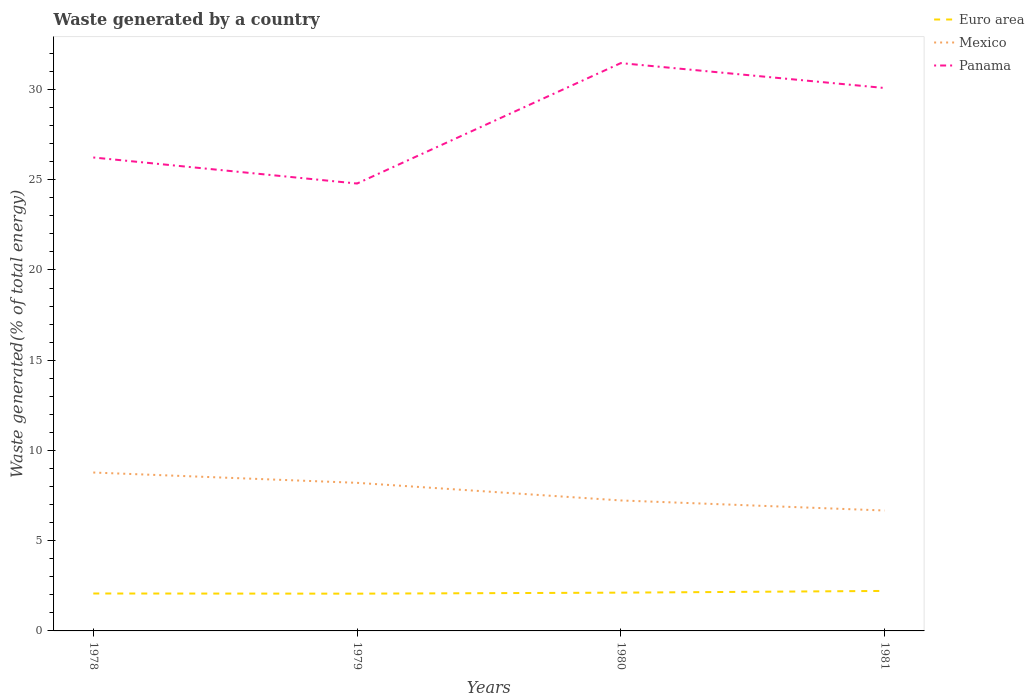How many different coloured lines are there?
Ensure brevity in your answer.  3. Across all years, what is the maximum total waste generated in Mexico?
Make the answer very short. 6.67. In which year was the total waste generated in Panama maximum?
Provide a succinct answer. 1979. What is the total total waste generated in Mexico in the graph?
Offer a terse response. 1.53. What is the difference between the highest and the second highest total waste generated in Mexico?
Provide a short and direct response. 2.11. What is the difference between the highest and the lowest total waste generated in Panama?
Offer a terse response. 2. How many years are there in the graph?
Provide a succinct answer. 4. Are the values on the major ticks of Y-axis written in scientific E-notation?
Offer a very short reply. No. How are the legend labels stacked?
Make the answer very short. Vertical. What is the title of the graph?
Your answer should be very brief. Waste generated by a country. What is the label or title of the X-axis?
Your response must be concise. Years. What is the label or title of the Y-axis?
Give a very brief answer. Waste generated(% of total energy). What is the Waste generated(% of total energy) in Euro area in 1978?
Your response must be concise. 2.07. What is the Waste generated(% of total energy) in Mexico in 1978?
Provide a short and direct response. 8.78. What is the Waste generated(% of total energy) in Panama in 1978?
Your answer should be very brief. 26.23. What is the Waste generated(% of total energy) in Euro area in 1979?
Your answer should be very brief. 2.06. What is the Waste generated(% of total energy) of Mexico in 1979?
Offer a very short reply. 8.21. What is the Waste generated(% of total energy) of Panama in 1979?
Make the answer very short. 24.79. What is the Waste generated(% of total energy) of Euro area in 1980?
Provide a short and direct response. 2.12. What is the Waste generated(% of total energy) of Mexico in 1980?
Make the answer very short. 7.23. What is the Waste generated(% of total energy) of Panama in 1980?
Offer a terse response. 31.46. What is the Waste generated(% of total energy) in Euro area in 1981?
Make the answer very short. 2.22. What is the Waste generated(% of total energy) in Mexico in 1981?
Your response must be concise. 6.67. What is the Waste generated(% of total energy) of Panama in 1981?
Offer a terse response. 30.08. Across all years, what is the maximum Waste generated(% of total energy) of Euro area?
Make the answer very short. 2.22. Across all years, what is the maximum Waste generated(% of total energy) in Mexico?
Provide a short and direct response. 8.78. Across all years, what is the maximum Waste generated(% of total energy) of Panama?
Your response must be concise. 31.46. Across all years, what is the minimum Waste generated(% of total energy) in Euro area?
Your response must be concise. 2.06. Across all years, what is the minimum Waste generated(% of total energy) in Mexico?
Provide a succinct answer. 6.67. Across all years, what is the minimum Waste generated(% of total energy) in Panama?
Give a very brief answer. 24.79. What is the total Waste generated(% of total energy) in Euro area in the graph?
Provide a short and direct response. 8.48. What is the total Waste generated(% of total energy) of Mexico in the graph?
Provide a succinct answer. 30.89. What is the total Waste generated(% of total energy) of Panama in the graph?
Give a very brief answer. 112.57. What is the difference between the Waste generated(% of total energy) in Euro area in 1978 and that in 1979?
Your answer should be compact. 0.01. What is the difference between the Waste generated(% of total energy) of Mexico in 1978 and that in 1979?
Provide a succinct answer. 0.57. What is the difference between the Waste generated(% of total energy) of Panama in 1978 and that in 1979?
Your response must be concise. 1.44. What is the difference between the Waste generated(% of total energy) of Euro area in 1978 and that in 1980?
Provide a short and direct response. -0.05. What is the difference between the Waste generated(% of total energy) of Mexico in 1978 and that in 1980?
Provide a short and direct response. 1.55. What is the difference between the Waste generated(% of total energy) of Panama in 1978 and that in 1980?
Your response must be concise. -5.23. What is the difference between the Waste generated(% of total energy) of Euro area in 1978 and that in 1981?
Your answer should be compact. -0.14. What is the difference between the Waste generated(% of total energy) in Mexico in 1978 and that in 1981?
Your answer should be very brief. 2.11. What is the difference between the Waste generated(% of total energy) of Panama in 1978 and that in 1981?
Your response must be concise. -3.85. What is the difference between the Waste generated(% of total energy) of Euro area in 1979 and that in 1980?
Provide a succinct answer. -0.06. What is the difference between the Waste generated(% of total energy) in Mexico in 1979 and that in 1980?
Your answer should be compact. 0.98. What is the difference between the Waste generated(% of total energy) in Panama in 1979 and that in 1980?
Give a very brief answer. -6.67. What is the difference between the Waste generated(% of total energy) of Euro area in 1979 and that in 1981?
Provide a short and direct response. -0.15. What is the difference between the Waste generated(% of total energy) in Mexico in 1979 and that in 1981?
Keep it short and to the point. 1.53. What is the difference between the Waste generated(% of total energy) of Panama in 1979 and that in 1981?
Offer a very short reply. -5.29. What is the difference between the Waste generated(% of total energy) in Euro area in 1980 and that in 1981?
Offer a terse response. -0.1. What is the difference between the Waste generated(% of total energy) in Mexico in 1980 and that in 1981?
Provide a succinct answer. 0.56. What is the difference between the Waste generated(% of total energy) in Panama in 1980 and that in 1981?
Provide a short and direct response. 1.38. What is the difference between the Waste generated(% of total energy) of Euro area in 1978 and the Waste generated(% of total energy) of Mexico in 1979?
Give a very brief answer. -6.13. What is the difference between the Waste generated(% of total energy) of Euro area in 1978 and the Waste generated(% of total energy) of Panama in 1979?
Your answer should be very brief. -22.72. What is the difference between the Waste generated(% of total energy) in Mexico in 1978 and the Waste generated(% of total energy) in Panama in 1979?
Your answer should be very brief. -16.01. What is the difference between the Waste generated(% of total energy) in Euro area in 1978 and the Waste generated(% of total energy) in Mexico in 1980?
Provide a short and direct response. -5.16. What is the difference between the Waste generated(% of total energy) in Euro area in 1978 and the Waste generated(% of total energy) in Panama in 1980?
Offer a very short reply. -29.39. What is the difference between the Waste generated(% of total energy) in Mexico in 1978 and the Waste generated(% of total energy) in Panama in 1980?
Your answer should be compact. -22.69. What is the difference between the Waste generated(% of total energy) of Euro area in 1978 and the Waste generated(% of total energy) of Mexico in 1981?
Make the answer very short. -4.6. What is the difference between the Waste generated(% of total energy) in Euro area in 1978 and the Waste generated(% of total energy) in Panama in 1981?
Keep it short and to the point. -28.01. What is the difference between the Waste generated(% of total energy) of Mexico in 1978 and the Waste generated(% of total energy) of Panama in 1981?
Offer a terse response. -21.31. What is the difference between the Waste generated(% of total energy) in Euro area in 1979 and the Waste generated(% of total energy) in Mexico in 1980?
Keep it short and to the point. -5.17. What is the difference between the Waste generated(% of total energy) in Euro area in 1979 and the Waste generated(% of total energy) in Panama in 1980?
Make the answer very short. -29.4. What is the difference between the Waste generated(% of total energy) in Mexico in 1979 and the Waste generated(% of total energy) in Panama in 1980?
Your answer should be very brief. -23.26. What is the difference between the Waste generated(% of total energy) in Euro area in 1979 and the Waste generated(% of total energy) in Mexico in 1981?
Your answer should be very brief. -4.61. What is the difference between the Waste generated(% of total energy) in Euro area in 1979 and the Waste generated(% of total energy) in Panama in 1981?
Your answer should be very brief. -28.02. What is the difference between the Waste generated(% of total energy) in Mexico in 1979 and the Waste generated(% of total energy) in Panama in 1981?
Keep it short and to the point. -21.88. What is the difference between the Waste generated(% of total energy) of Euro area in 1980 and the Waste generated(% of total energy) of Mexico in 1981?
Ensure brevity in your answer.  -4.55. What is the difference between the Waste generated(% of total energy) in Euro area in 1980 and the Waste generated(% of total energy) in Panama in 1981?
Ensure brevity in your answer.  -27.96. What is the difference between the Waste generated(% of total energy) of Mexico in 1980 and the Waste generated(% of total energy) of Panama in 1981?
Your answer should be compact. -22.85. What is the average Waste generated(% of total energy) in Euro area per year?
Provide a short and direct response. 2.12. What is the average Waste generated(% of total energy) in Mexico per year?
Provide a short and direct response. 7.72. What is the average Waste generated(% of total energy) of Panama per year?
Offer a terse response. 28.14. In the year 1978, what is the difference between the Waste generated(% of total energy) of Euro area and Waste generated(% of total energy) of Mexico?
Your answer should be very brief. -6.7. In the year 1978, what is the difference between the Waste generated(% of total energy) in Euro area and Waste generated(% of total energy) in Panama?
Your answer should be very brief. -24.16. In the year 1978, what is the difference between the Waste generated(% of total energy) in Mexico and Waste generated(% of total energy) in Panama?
Your response must be concise. -17.46. In the year 1979, what is the difference between the Waste generated(% of total energy) in Euro area and Waste generated(% of total energy) in Mexico?
Your answer should be compact. -6.14. In the year 1979, what is the difference between the Waste generated(% of total energy) in Euro area and Waste generated(% of total energy) in Panama?
Offer a terse response. -22.73. In the year 1979, what is the difference between the Waste generated(% of total energy) in Mexico and Waste generated(% of total energy) in Panama?
Your answer should be compact. -16.58. In the year 1980, what is the difference between the Waste generated(% of total energy) of Euro area and Waste generated(% of total energy) of Mexico?
Provide a succinct answer. -5.11. In the year 1980, what is the difference between the Waste generated(% of total energy) of Euro area and Waste generated(% of total energy) of Panama?
Give a very brief answer. -29.34. In the year 1980, what is the difference between the Waste generated(% of total energy) in Mexico and Waste generated(% of total energy) in Panama?
Keep it short and to the point. -24.23. In the year 1981, what is the difference between the Waste generated(% of total energy) of Euro area and Waste generated(% of total energy) of Mexico?
Your answer should be compact. -4.46. In the year 1981, what is the difference between the Waste generated(% of total energy) in Euro area and Waste generated(% of total energy) in Panama?
Your response must be concise. -27.87. In the year 1981, what is the difference between the Waste generated(% of total energy) in Mexico and Waste generated(% of total energy) in Panama?
Your answer should be compact. -23.41. What is the ratio of the Waste generated(% of total energy) of Mexico in 1978 to that in 1979?
Give a very brief answer. 1.07. What is the ratio of the Waste generated(% of total energy) of Panama in 1978 to that in 1979?
Your answer should be very brief. 1.06. What is the ratio of the Waste generated(% of total energy) of Euro area in 1978 to that in 1980?
Make the answer very short. 0.98. What is the ratio of the Waste generated(% of total energy) in Mexico in 1978 to that in 1980?
Offer a very short reply. 1.21. What is the ratio of the Waste generated(% of total energy) in Panama in 1978 to that in 1980?
Provide a short and direct response. 0.83. What is the ratio of the Waste generated(% of total energy) of Euro area in 1978 to that in 1981?
Ensure brevity in your answer.  0.94. What is the ratio of the Waste generated(% of total energy) in Mexico in 1978 to that in 1981?
Ensure brevity in your answer.  1.32. What is the ratio of the Waste generated(% of total energy) of Panama in 1978 to that in 1981?
Offer a very short reply. 0.87. What is the ratio of the Waste generated(% of total energy) of Euro area in 1979 to that in 1980?
Make the answer very short. 0.97. What is the ratio of the Waste generated(% of total energy) in Mexico in 1979 to that in 1980?
Make the answer very short. 1.14. What is the ratio of the Waste generated(% of total energy) of Panama in 1979 to that in 1980?
Make the answer very short. 0.79. What is the ratio of the Waste generated(% of total energy) in Euro area in 1979 to that in 1981?
Ensure brevity in your answer.  0.93. What is the ratio of the Waste generated(% of total energy) in Mexico in 1979 to that in 1981?
Provide a short and direct response. 1.23. What is the ratio of the Waste generated(% of total energy) of Panama in 1979 to that in 1981?
Ensure brevity in your answer.  0.82. What is the ratio of the Waste generated(% of total energy) in Mexico in 1980 to that in 1981?
Your answer should be very brief. 1.08. What is the ratio of the Waste generated(% of total energy) of Panama in 1980 to that in 1981?
Your response must be concise. 1.05. What is the difference between the highest and the second highest Waste generated(% of total energy) in Euro area?
Offer a very short reply. 0.1. What is the difference between the highest and the second highest Waste generated(% of total energy) in Mexico?
Provide a succinct answer. 0.57. What is the difference between the highest and the second highest Waste generated(% of total energy) in Panama?
Offer a very short reply. 1.38. What is the difference between the highest and the lowest Waste generated(% of total energy) in Euro area?
Provide a short and direct response. 0.15. What is the difference between the highest and the lowest Waste generated(% of total energy) of Mexico?
Provide a short and direct response. 2.11. What is the difference between the highest and the lowest Waste generated(% of total energy) of Panama?
Your answer should be very brief. 6.67. 